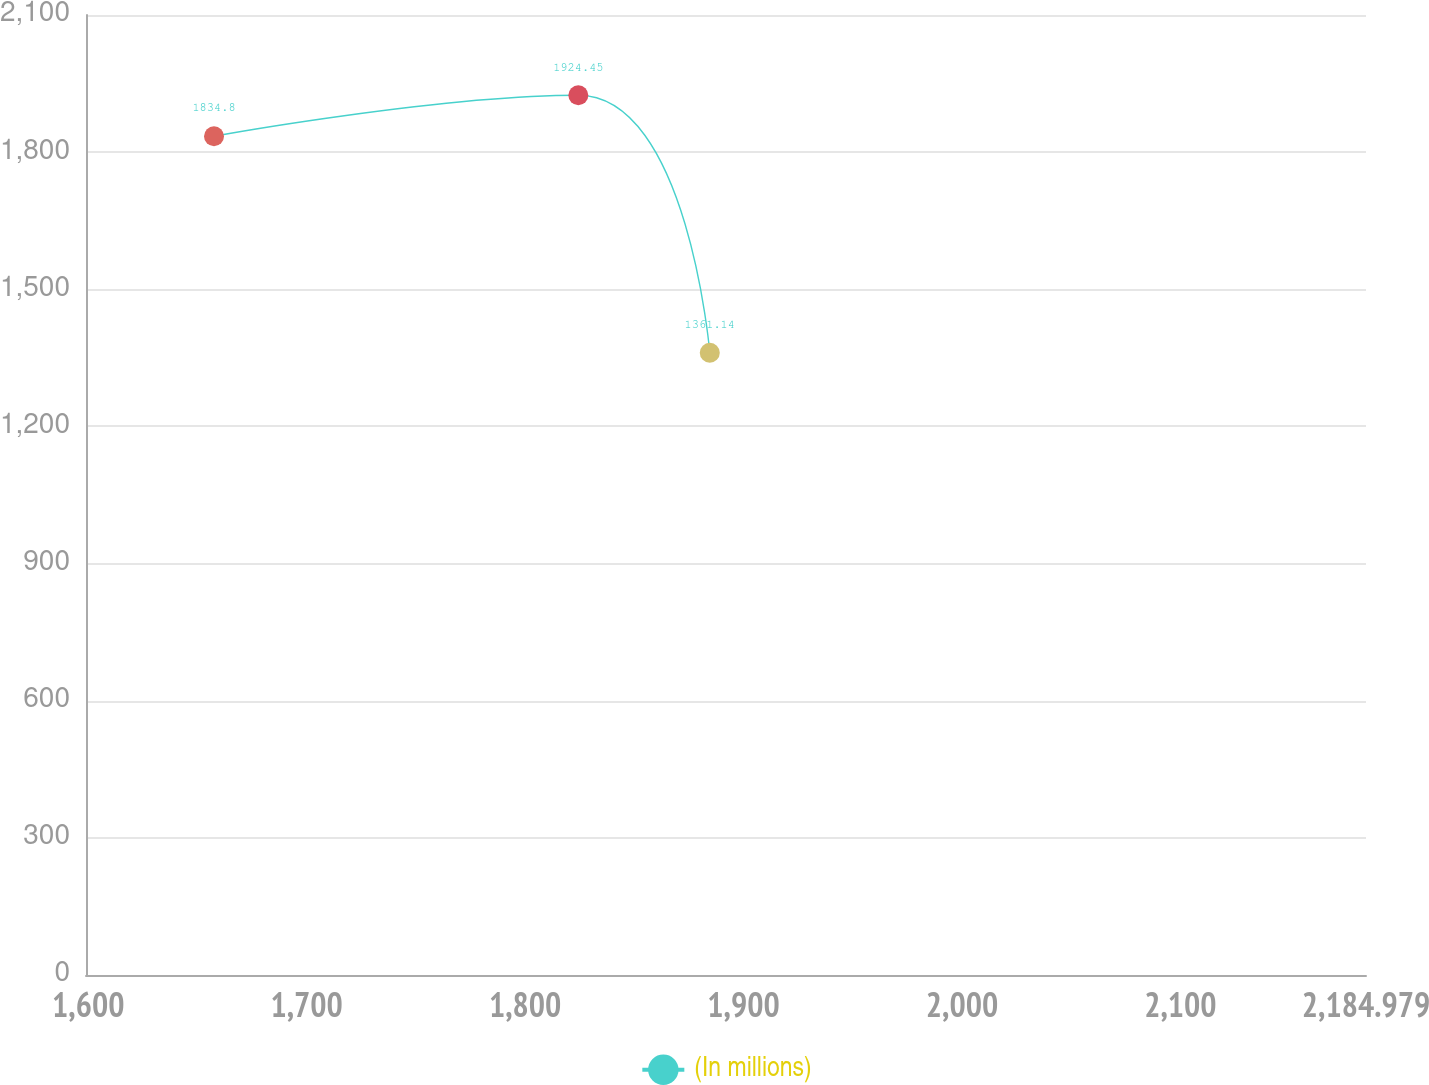<chart> <loc_0><loc_0><loc_500><loc_500><line_chart><ecel><fcel>(In millions)<nl><fcel>1657.57<fcel>1834.8<nl><fcel>1824.37<fcel>1924.45<nl><fcel>1884.55<fcel>1361.14<nl><fcel>2190.14<fcel>1190.53<nl><fcel>2243.58<fcel>952.25<nl></chart> 